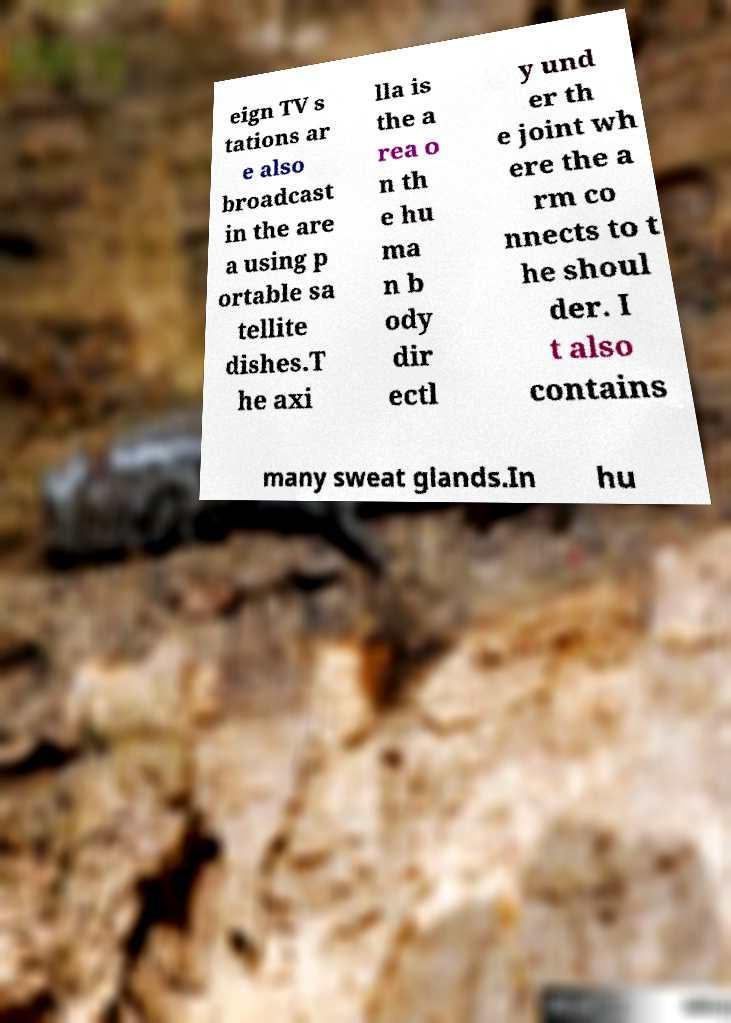Can you accurately transcribe the text from the provided image for me? eign TV s tations ar e also broadcast in the are a using p ortable sa tellite dishes.T he axi lla is the a rea o n th e hu ma n b ody dir ectl y und er th e joint wh ere the a rm co nnects to t he shoul der. I t also contains many sweat glands.In hu 